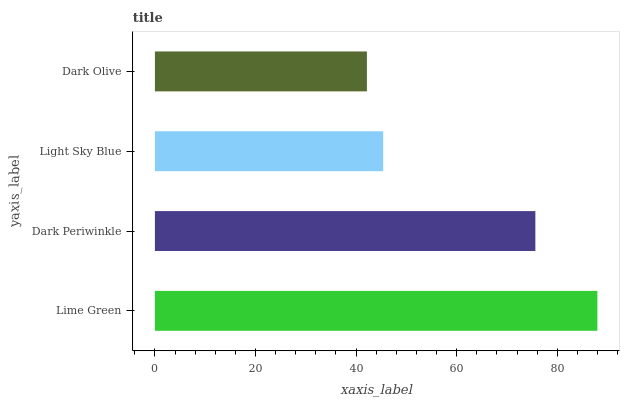Is Dark Olive the minimum?
Answer yes or no. Yes. Is Lime Green the maximum?
Answer yes or no. Yes. Is Dark Periwinkle the minimum?
Answer yes or no. No. Is Dark Periwinkle the maximum?
Answer yes or no. No. Is Lime Green greater than Dark Periwinkle?
Answer yes or no. Yes. Is Dark Periwinkle less than Lime Green?
Answer yes or no. Yes. Is Dark Periwinkle greater than Lime Green?
Answer yes or no. No. Is Lime Green less than Dark Periwinkle?
Answer yes or no. No. Is Dark Periwinkle the high median?
Answer yes or no. Yes. Is Light Sky Blue the low median?
Answer yes or no. Yes. Is Dark Olive the high median?
Answer yes or no. No. Is Dark Olive the low median?
Answer yes or no. No. 